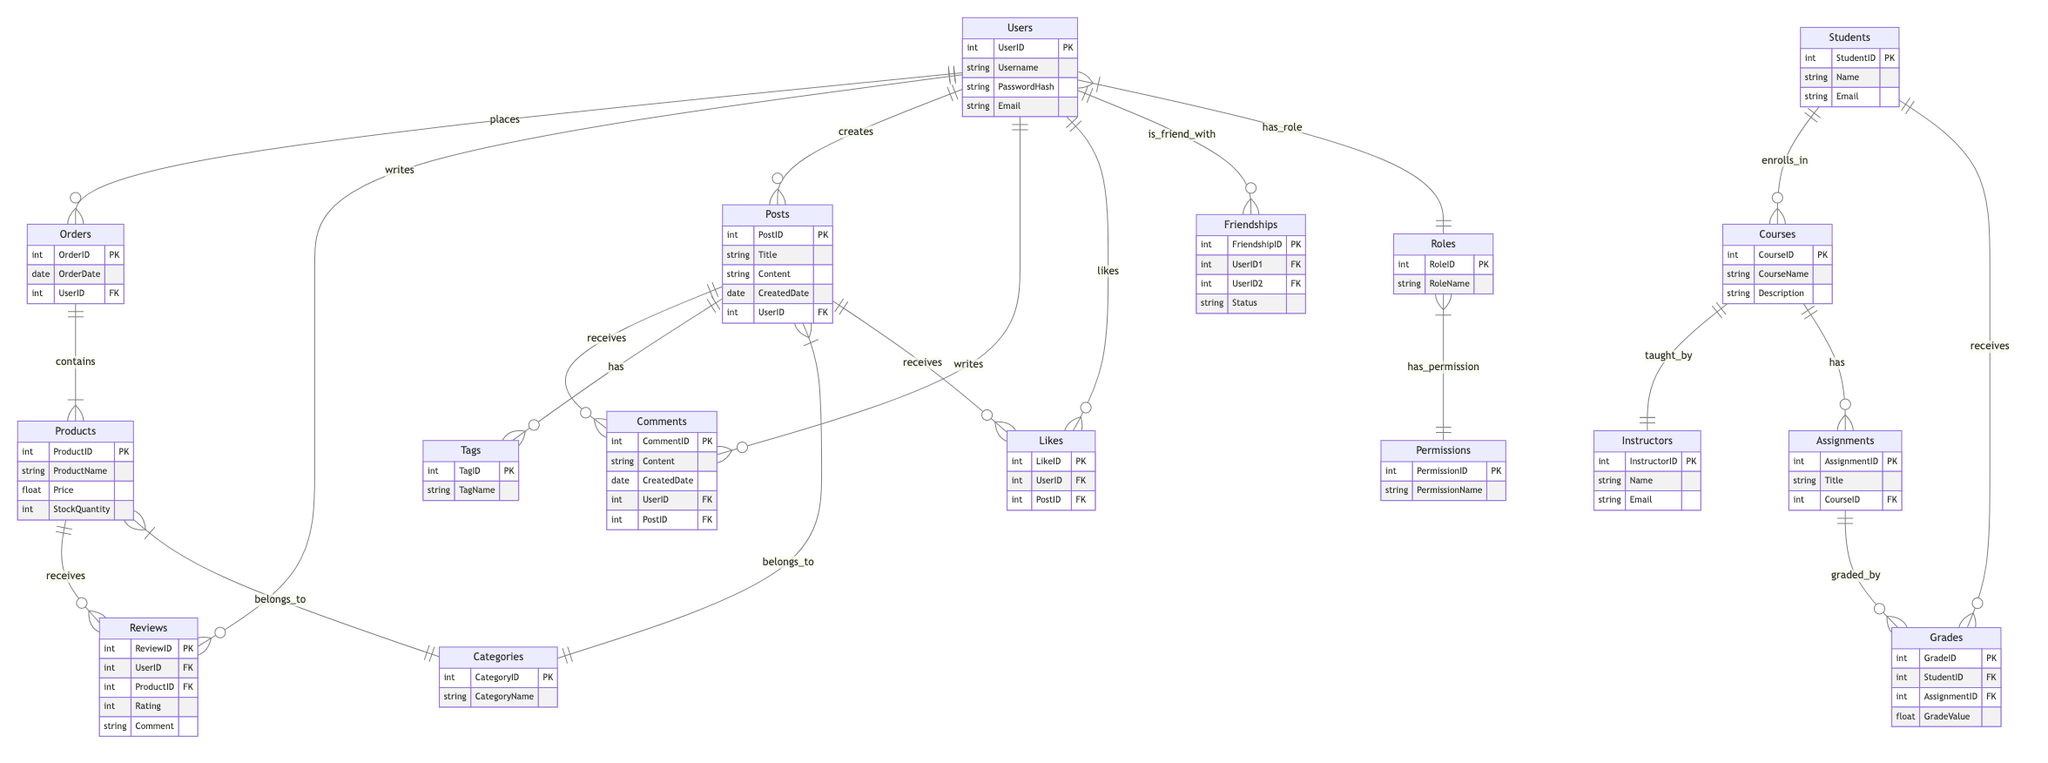What are the entities in the User Authentication System? The entities listed in the diagram are Users, Roles, and Permissions.
Answer: Users, Roles, Permissions How many relationships are there in the E-commerce Platform? The E-commerce Platform diagram has five relationships: places, contains, writes, belongs to, and receives.
Answer: Five What role is associated with permissions? The relationship "has_permission" indicates that a Role is associated with Permissions in the User Authentication System.
Answer: Role What is the Rating attribute in the Reviews entity? The Rating attribute measures how well a product is perceived by a user, allowing users to provide quantitative feedback on products.
Answer: Rating Which entity can a Student enroll in according to the Online Course Management System? The relationship "enrolls_in" signifies that Students can enroll in Courses.
Answer: Courses How many entities are involved in the Blogging Platform? There are five entities involved in the Blogging Platform: Users, Posts, Comments, Tags, and Categories.
Answer: Five Which entity is responsible for creating posts in the Social Media Network? The Users entity is responsible for creating posts as shown by the relationship "creates" in the diagram.
Answer: Users What happens to a Post when it receives a comment? The relationship "receives" indicates that when a Post is interacted with, it can gather Comments, resulting in user engagement on that post.
Answer: Receives From which entity does an Assignment get graded in the Online Course Management System? The relationship "graded_by" indicates that Grades are provided based on Assignments in the Online Course Management System.
Answer: Assignment Which entity do Products belong to in the E-commerce Platform? The relationship "belongs_to" shows that Products are categorized under Categories in the E-commerce Platform.
Answer: Categories 